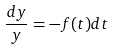<formula> <loc_0><loc_0><loc_500><loc_500>\frac { d y } { y } = - f ( t ) d t</formula> 